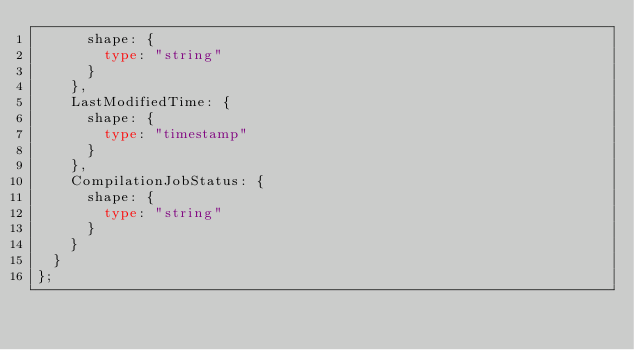Convert code to text. <code><loc_0><loc_0><loc_500><loc_500><_TypeScript_>      shape: {
        type: "string"
      }
    },
    LastModifiedTime: {
      shape: {
        type: "timestamp"
      }
    },
    CompilationJobStatus: {
      shape: {
        type: "string"
      }
    }
  }
};
</code> 